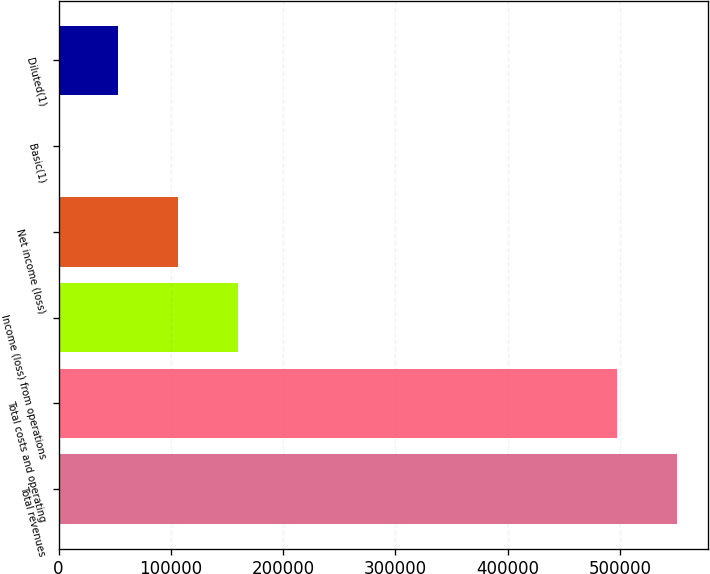<chart> <loc_0><loc_0><loc_500><loc_500><bar_chart><fcel>Total revenues<fcel>Total costs and operating<fcel>Income (loss) from operations<fcel>Net income (loss)<fcel>Basic(1)<fcel>Diluted(1)<nl><fcel>550826<fcel>497575<fcel>159754<fcel>106503<fcel>0.11<fcel>53251.4<nl></chart> 